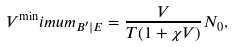<formula> <loc_0><loc_0><loc_500><loc_500>V ^ { \min } i m u m _ { B ^ { \prime } | E } = \frac { V } { T ( 1 + \chi V ) } N _ { 0 } ,</formula> 